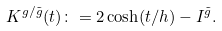<formula> <loc_0><loc_0><loc_500><loc_500>K ^ { g / \tilde { g } } ( t ) \colon = 2 \cosh ( t / h ) - I ^ { \tilde { g } } .</formula> 